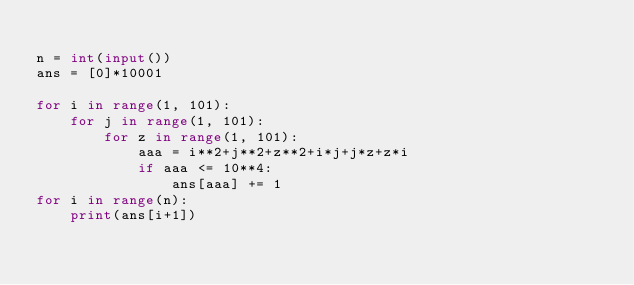Convert code to text. <code><loc_0><loc_0><loc_500><loc_500><_Python_>
n = int(input())
ans = [0]*10001

for i in range(1, 101):
    for j in range(1, 101):
        for z in range(1, 101):
            aaa = i**2+j**2+z**2+i*j+j*z+z*i
            if aaa <= 10**4:
                ans[aaa] += 1
for i in range(n):
    print(ans[i+1])
</code> 